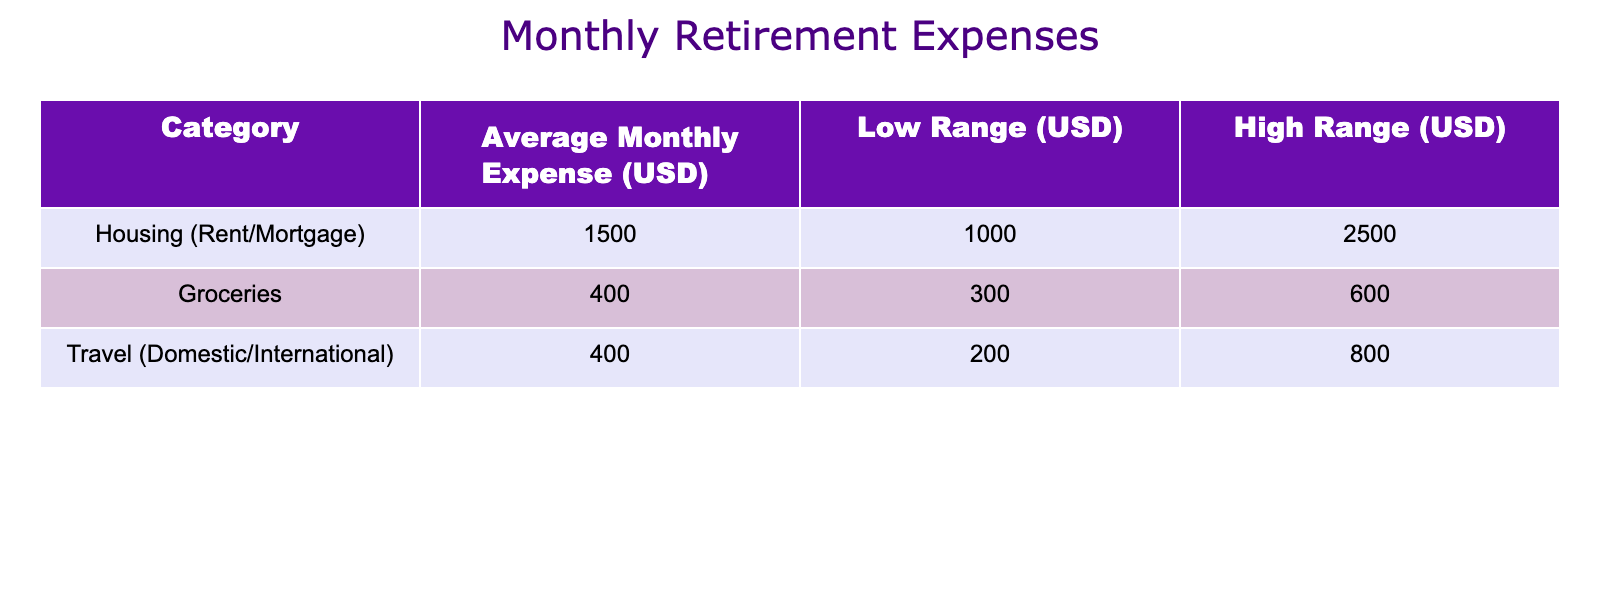What is the average monthly expense for housing? The average monthly expense for housing according to the table is listed directly under the "Average Monthly Expense (USD)" column for the "Housing (Rent/Mortgage)" row, which is 1500.
Answer: 1500 What is the low range for grocery expenses? The low range for grocery expenses can be found in the "Low Range (USD)" column for the "Groceries" row, which is stated as 300.
Answer: 300 How much higher is the average expense for housing compared to travel? The average expense for housing is 1500, and the average expense for travel is 400. To find the difference, subtract the travel expense from the housing expense: 1500 - 400 = 1100.
Answer: 1100 Is the average monthly travel expense greater than the low range for groceries? The average monthly travel expense is 400, and the low range for groceries is 300. Since 400 is greater than 300, the statement is true.
Answer: Yes What is the total of the high ranges for housing, groceries, and travel? To find the total high range, add the high ranges of all categories: Housing (2500) + Groceries (600) + Travel (800) = 3900.
Answer: 3900 What is the highest average monthly expense among the categories? By comparing the average expenses listed: Housing (1500), Groceries (400), and Travel (400), the highest value is from the Housing category, which is 1500.
Answer: 1500 Are the high range and low range values for travel the same as for groceries? The high range for travel is 800 and the low range is 200, while the high range for groceries is 600 and the low range is 300. These values are not the same, making the statement false.
Answer: No What percentage of the total average monthly expenses does travel expenses represent? First, calculate the total average expenses: 1500 (Housing) + 400 (Groceries) + 400 (Travel) = 2300. Now find the percentage that travel expenses represent: (400 / 2300) * 100 = approximately 17.39%.
Answer: 17.39 If the average monthly expense for groceries increased by 100, what would the new average be? The current average for groceries is 400. If we add 100 to it, the new average would be 400 + 100 = 500.
Answer: 500 